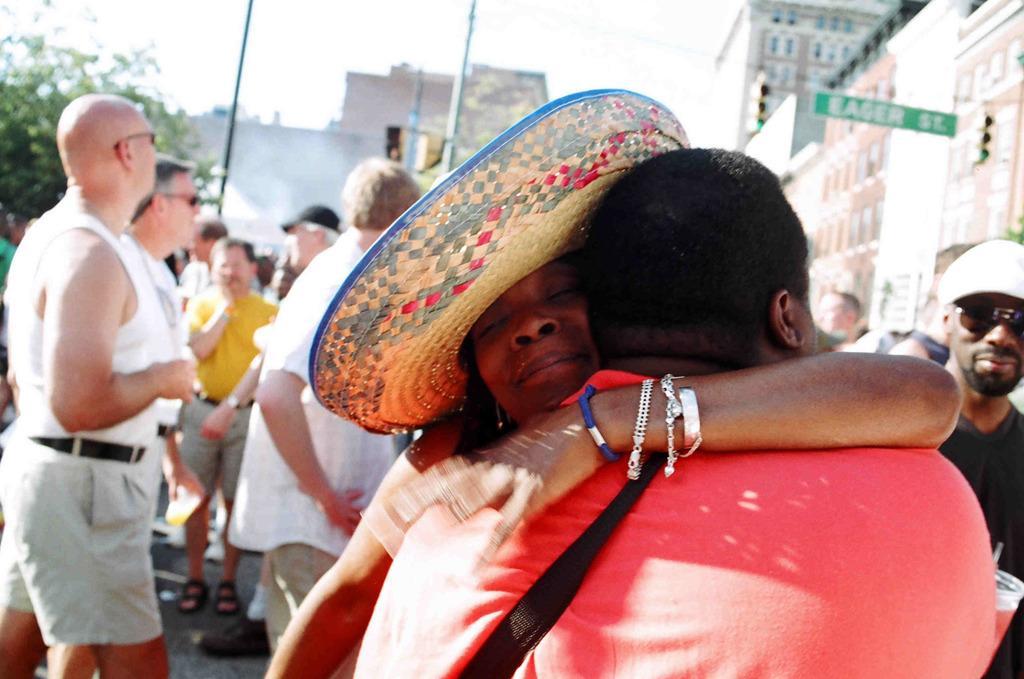Describe this image in one or two sentences. There is a couple standing and hugging each other and there are few persons behind them and there are buildings in the background. 